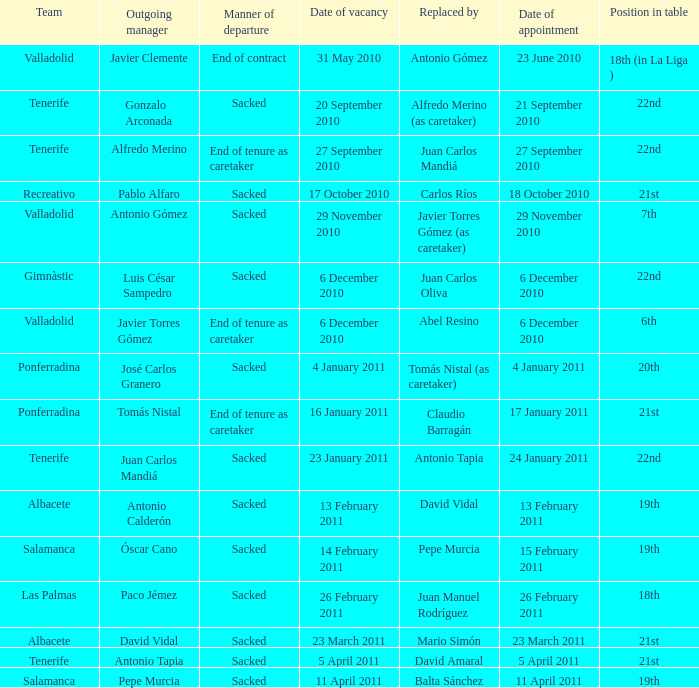What was the appointed position on january 17, 2011? 21st. 